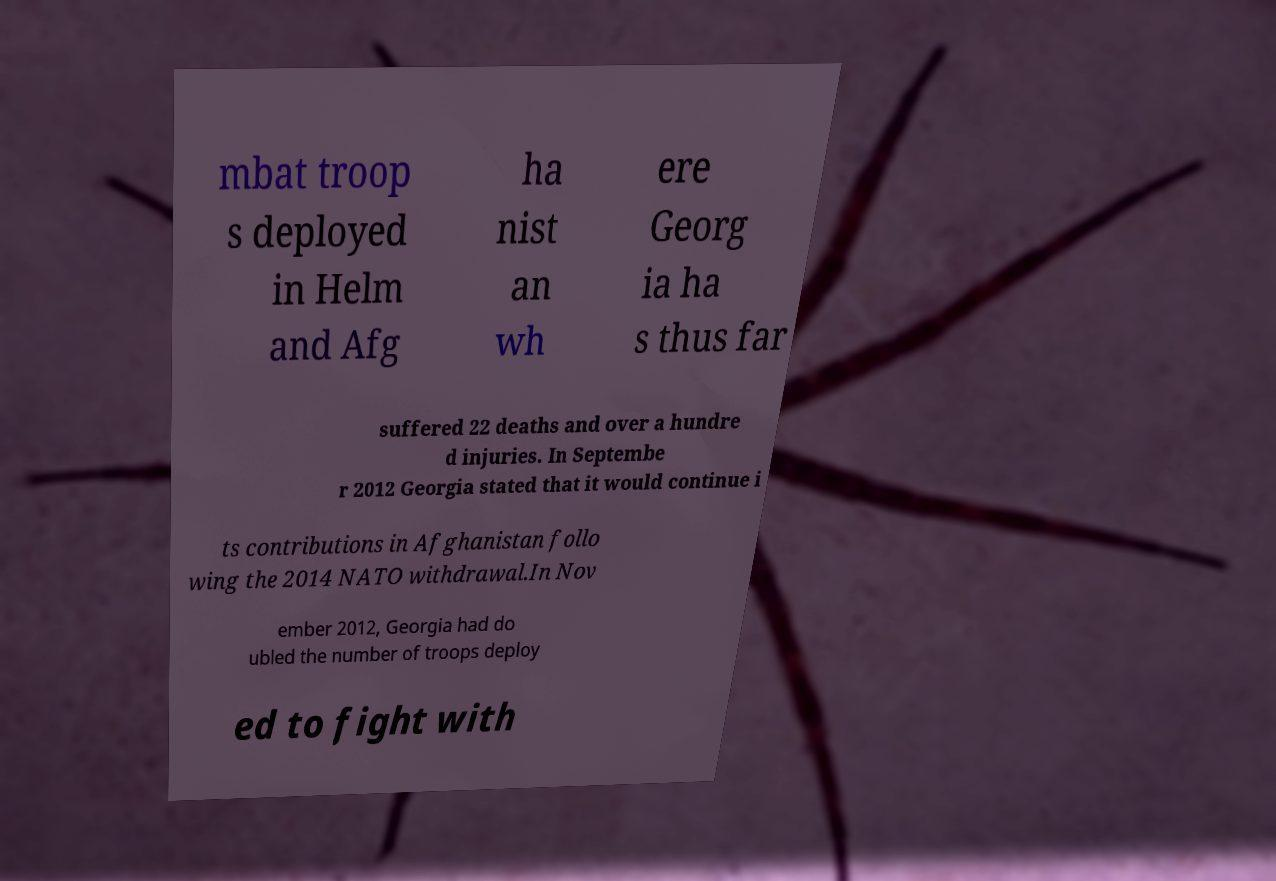Please read and relay the text visible in this image. What does it say? mbat troop s deployed in Helm and Afg ha nist an wh ere Georg ia ha s thus far suffered 22 deaths and over a hundre d injuries. In Septembe r 2012 Georgia stated that it would continue i ts contributions in Afghanistan follo wing the 2014 NATO withdrawal.In Nov ember 2012, Georgia had do ubled the number of troops deploy ed to fight with 